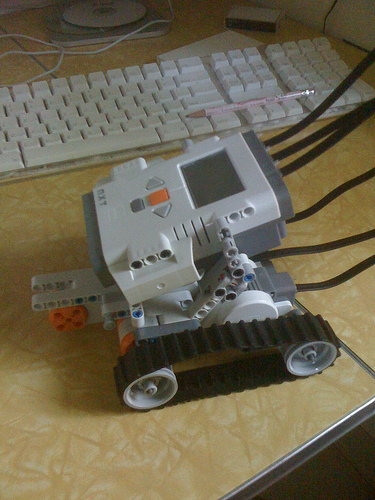<image>
Is the keyboard above the machine? No. The keyboard is not positioned above the machine. The vertical arrangement shows a different relationship. 